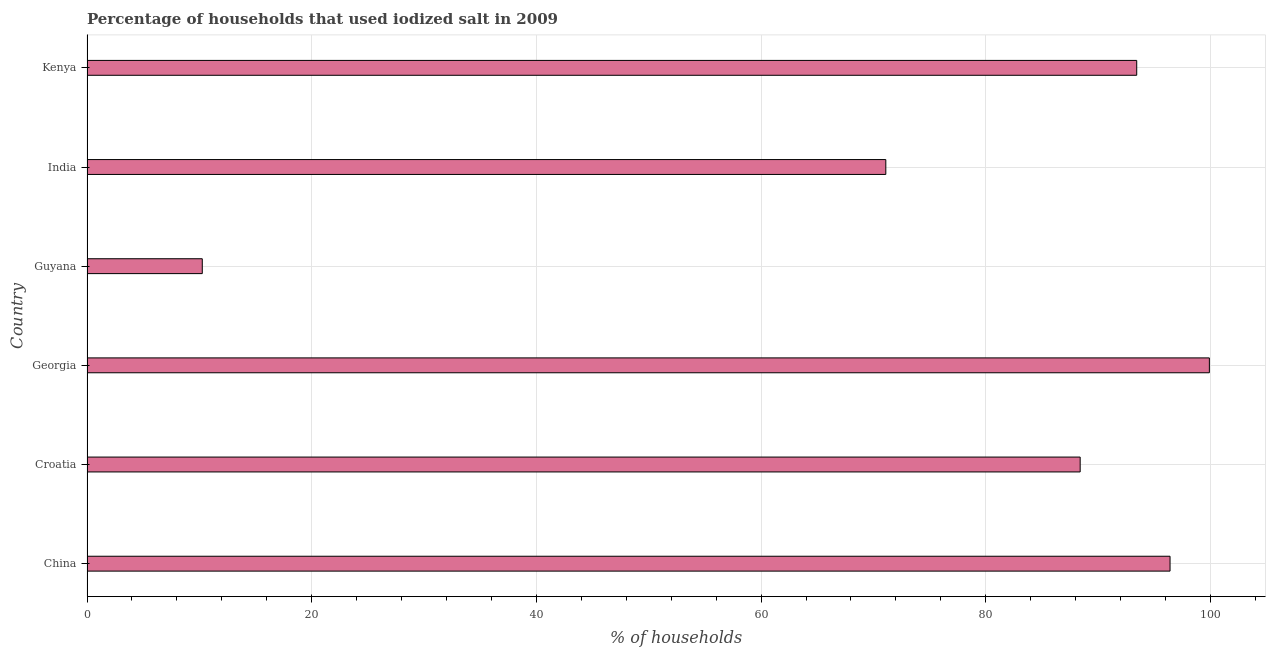Does the graph contain grids?
Ensure brevity in your answer.  Yes. What is the title of the graph?
Ensure brevity in your answer.  Percentage of households that used iodized salt in 2009. What is the label or title of the X-axis?
Provide a succinct answer. % of households. What is the percentage of households where iodized salt is consumed in Georgia?
Provide a succinct answer. 99.9. Across all countries, what is the maximum percentage of households where iodized salt is consumed?
Ensure brevity in your answer.  99.9. Across all countries, what is the minimum percentage of households where iodized salt is consumed?
Offer a very short reply. 10.26. In which country was the percentage of households where iodized salt is consumed maximum?
Ensure brevity in your answer.  Georgia. In which country was the percentage of households where iodized salt is consumed minimum?
Provide a succinct answer. Guyana. What is the sum of the percentage of households where iodized salt is consumed?
Offer a terse response. 459.49. What is the difference between the percentage of households where iodized salt is consumed in Guyana and India?
Offer a terse response. -60.84. What is the average percentage of households where iodized salt is consumed per country?
Your response must be concise. 76.58. What is the median percentage of households where iodized salt is consumed?
Keep it short and to the point. 90.92. In how many countries, is the percentage of households where iodized salt is consumed greater than 48 %?
Your answer should be very brief. 5. What is the ratio of the percentage of households where iodized salt is consumed in Croatia to that in Georgia?
Your answer should be very brief. 0.89. Is the difference between the percentage of households where iodized salt is consumed in China and Guyana greater than the difference between any two countries?
Your answer should be very brief. No. What is the difference between the highest and the lowest percentage of households where iodized salt is consumed?
Give a very brief answer. 89.64. Are all the bars in the graph horizontal?
Your answer should be very brief. Yes. How many countries are there in the graph?
Provide a short and direct response. 6. Are the values on the major ticks of X-axis written in scientific E-notation?
Your answer should be very brief. No. What is the % of households of China?
Your answer should be very brief. 96.4. What is the % of households in Croatia?
Your response must be concise. 88.4. What is the % of households in Georgia?
Make the answer very short. 99.9. What is the % of households of Guyana?
Your response must be concise. 10.26. What is the % of households of India?
Offer a terse response. 71.1. What is the % of households of Kenya?
Give a very brief answer. 93.43. What is the difference between the % of households in China and Croatia?
Offer a very short reply. 8. What is the difference between the % of households in China and Georgia?
Your answer should be very brief. -3.5. What is the difference between the % of households in China and Guyana?
Your response must be concise. 86.14. What is the difference between the % of households in China and India?
Provide a succinct answer. 25.3. What is the difference between the % of households in China and Kenya?
Offer a terse response. 2.97. What is the difference between the % of households in Croatia and Guyana?
Your response must be concise. 78.14. What is the difference between the % of households in Croatia and India?
Your response must be concise. 17.3. What is the difference between the % of households in Croatia and Kenya?
Ensure brevity in your answer.  -5.03. What is the difference between the % of households in Georgia and Guyana?
Ensure brevity in your answer.  89.64. What is the difference between the % of households in Georgia and India?
Give a very brief answer. 28.8. What is the difference between the % of households in Georgia and Kenya?
Give a very brief answer. 6.47. What is the difference between the % of households in Guyana and India?
Make the answer very short. -60.84. What is the difference between the % of households in Guyana and Kenya?
Provide a short and direct response. -83.17. What is the difference between the % of households in India and Kenya?
Offer a terse response. -22.33. What is the ratio of the % of households in China to that in Croatia?
Provide a short and direct response. 1.09. What is the ratio of the % of households in China to that in Guyana?
Provide a short and direct response. 9.39. What is the ratio of the % of households in China to that in India?
Provide a succinct answer. 1.36. What is the ratio of the % of households in China to that in Kenya?
Make the answer very short. 1.03. What is the ratio of the % of households in Croatia to that in Georgia?
Give a very brief answer. 0.89. What is the ratio of the % of households in Croatia to that in Guyana?
Your answer should be compact. 8.62. What is the ratio of the % of households in Croatia to that in India?
Your answer should be very brief. 1.24. What is the ratio of the % of households in Croatia to that in Kenya?
Your response must be concise. 0.95. What is the ratio of the % of households in Georgia to that in Guyana?
Offer a very short reply. 9.73. What is the ratio of the % of households in Georgia to that in India?
Offer a terse response. 1.41. What is the ratio of the % of households in Georgia to that in Kenya?
Provide a succinct answer. 1.07. What is the ratio of the % of households in Guyana to that in India?
Give a very brief answer. 0.14. What is the ratio of the % of households in Guyana to that in Kenya?
Ensure brevity in your answer.  0.11. What is the ratio of the % of households in India to that in Kenya?
Your answer should be very brief. 0.76. 